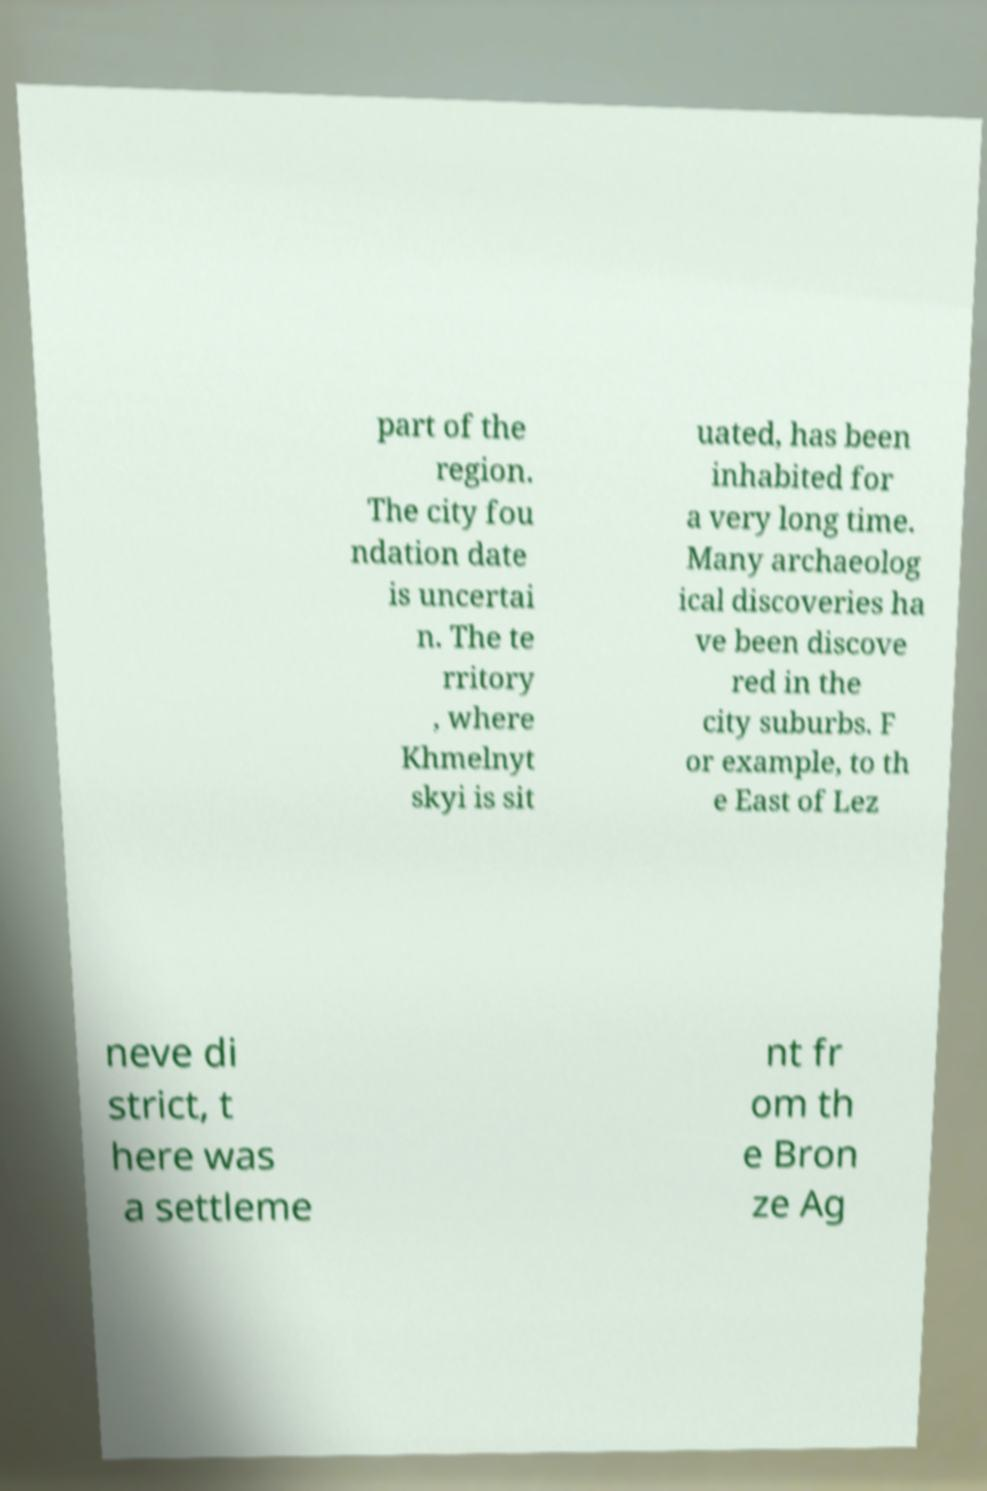Please identify and transcribe the text found in this image. part of the region. The city fou ndation date is uncertai n. The te rritory , where Khmelnyt skyi is sit uated, has been inhabited for a very long time. Many archaeolog ical discoveries ha ve been discove red in the city suburbs. F or example, to th e East of Lez neve di strict, t here was a settleme nt fr om th e Bron ze Ag 